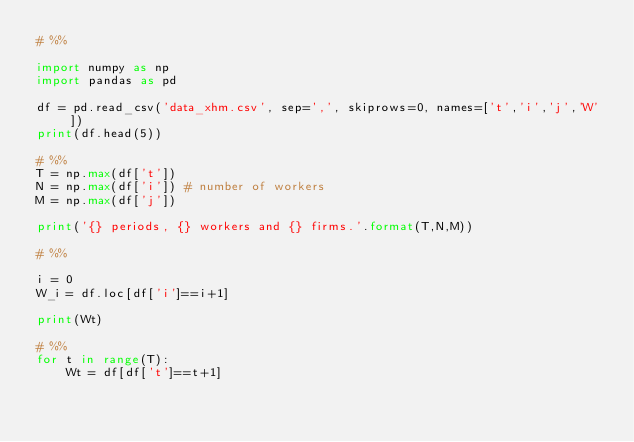<code> <loc_0><loc_0><loc_500><loc_500><_Python_># %%

import numpy as np 
import pandas as pd 

df = pd.read_csv('data_xhm.csv', sep=',', skiprows=0, names=['t','i','j','W'])
print(df.head(5))

# %%
T = np.max(df['t'])
N = np.max(df['i']) # number of workers
M = np.max(df['j']) 

print('{} periods, {} workers and {} firms.'.format(T,N,M))

# %%

i = 0
W_i = df.loc[df['i']==i+1]

print(Wt)

# %%
for t in range(T):
    Wt = df[df['t']==t+1]</code> 